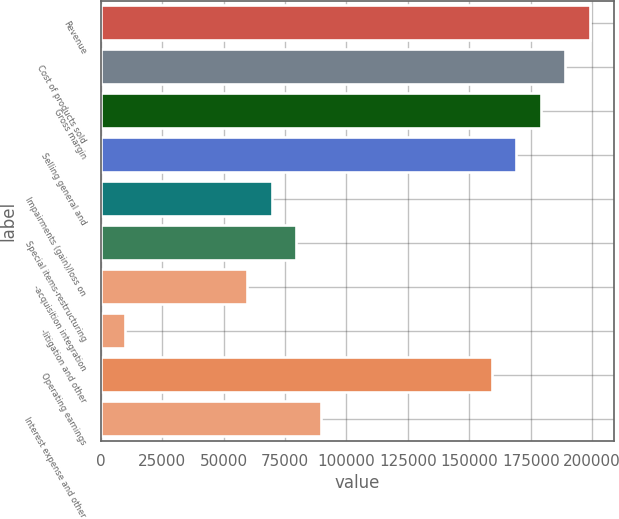Convert chart. <chart><loc_0><loc_0><loc_500><loc_500><bar_chart><fcel>Revenue<fcel>Cost of products sold<fcel>Gross margin<fcel>Selling general and<fcel>Impairments (gain)/loss on<fcel>Special items-restructuring<fcel>-acquisition integration<fcel>-litigation and other<fcel>Operating earnings<fcel>Interest expense and other<nl><fcel>199025<fcel>189074<fcel>179122<fcel>169171<fcel>69658.7<fcel>79609.9<fcel>59707.5<fcel>9951.26<fcel>159220<fcel>89561.2<nl></chart> 